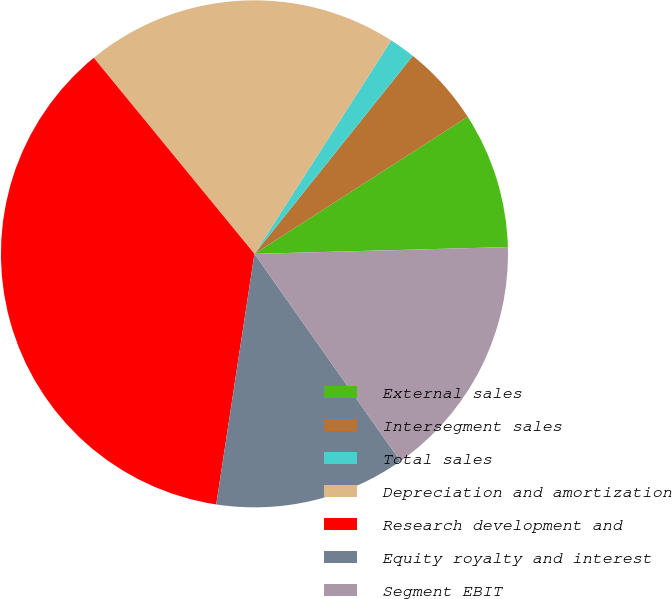<chart> <loc_0><loc_0><loc_500><loc_500><pie_chart><fcel>External sales<fcel>Intersegment sales<fcel>Total sales<fcel>Depreciation and amortization<fcel>Research development and<fcel>Equity royalty and interest<fcel>Segment EBIT<nl><fcel>8.67%<fcel>5.17%<fcel>1.67%<fcel>20.0%<fcel>36.67%<fcel>12.17%<fcel>15.67%<nl></chart> 